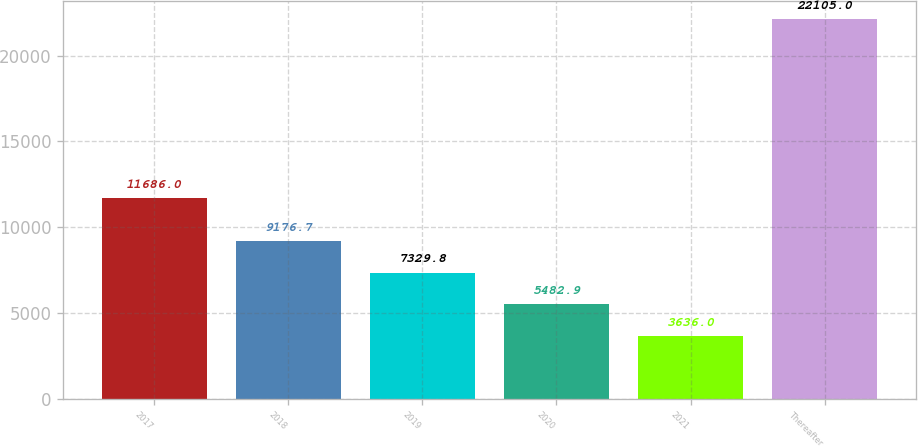Convert chart to OTSL. <chart><loc_0><loc_0><loc_500><loc_500><bar_chart><fcel>2017<fcel>2018<fcel>2019<fcel>2020<fcel>2021<fcel>Thereafter<nl><fcel>11686<fcel>9176.7<fcel>7329.8<fcel>5482.9<fcel>3636<fcel>22105<nl></chart> 